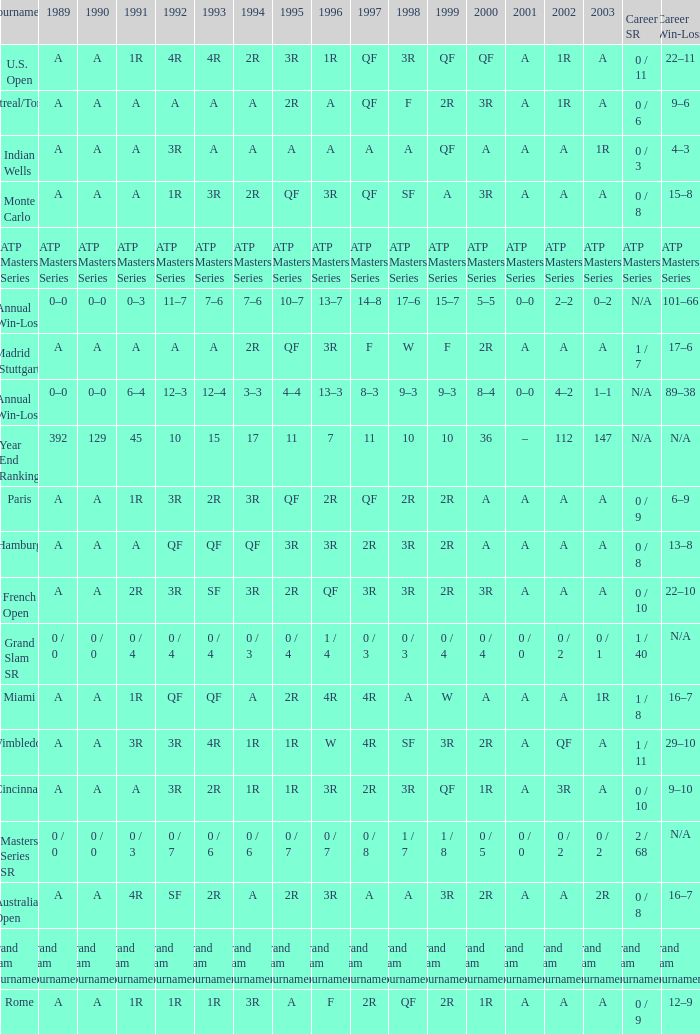What was the value in 1989 with QF in 1997 and A in 1993? A. 